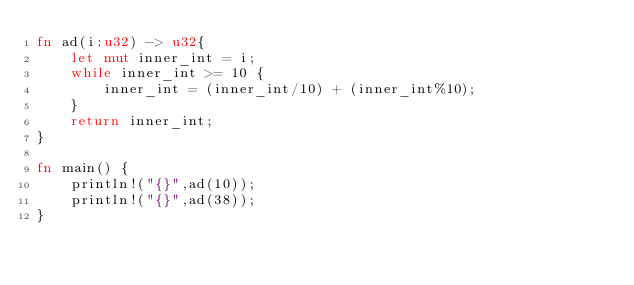<code> <loc_0><loc_0><loc_500><loc_500><_Rust_>fn ad(i:u32) -> u32{
    let mut inner_int = i;
    while inner_int >= 10 {
        inner_int = (inner_int/10) + (inner_int%10);
    }
    return inner_int;
}

fn main() {
    println!("{}",ad(10));
    println!("{}",ad(38));
}
</code> 